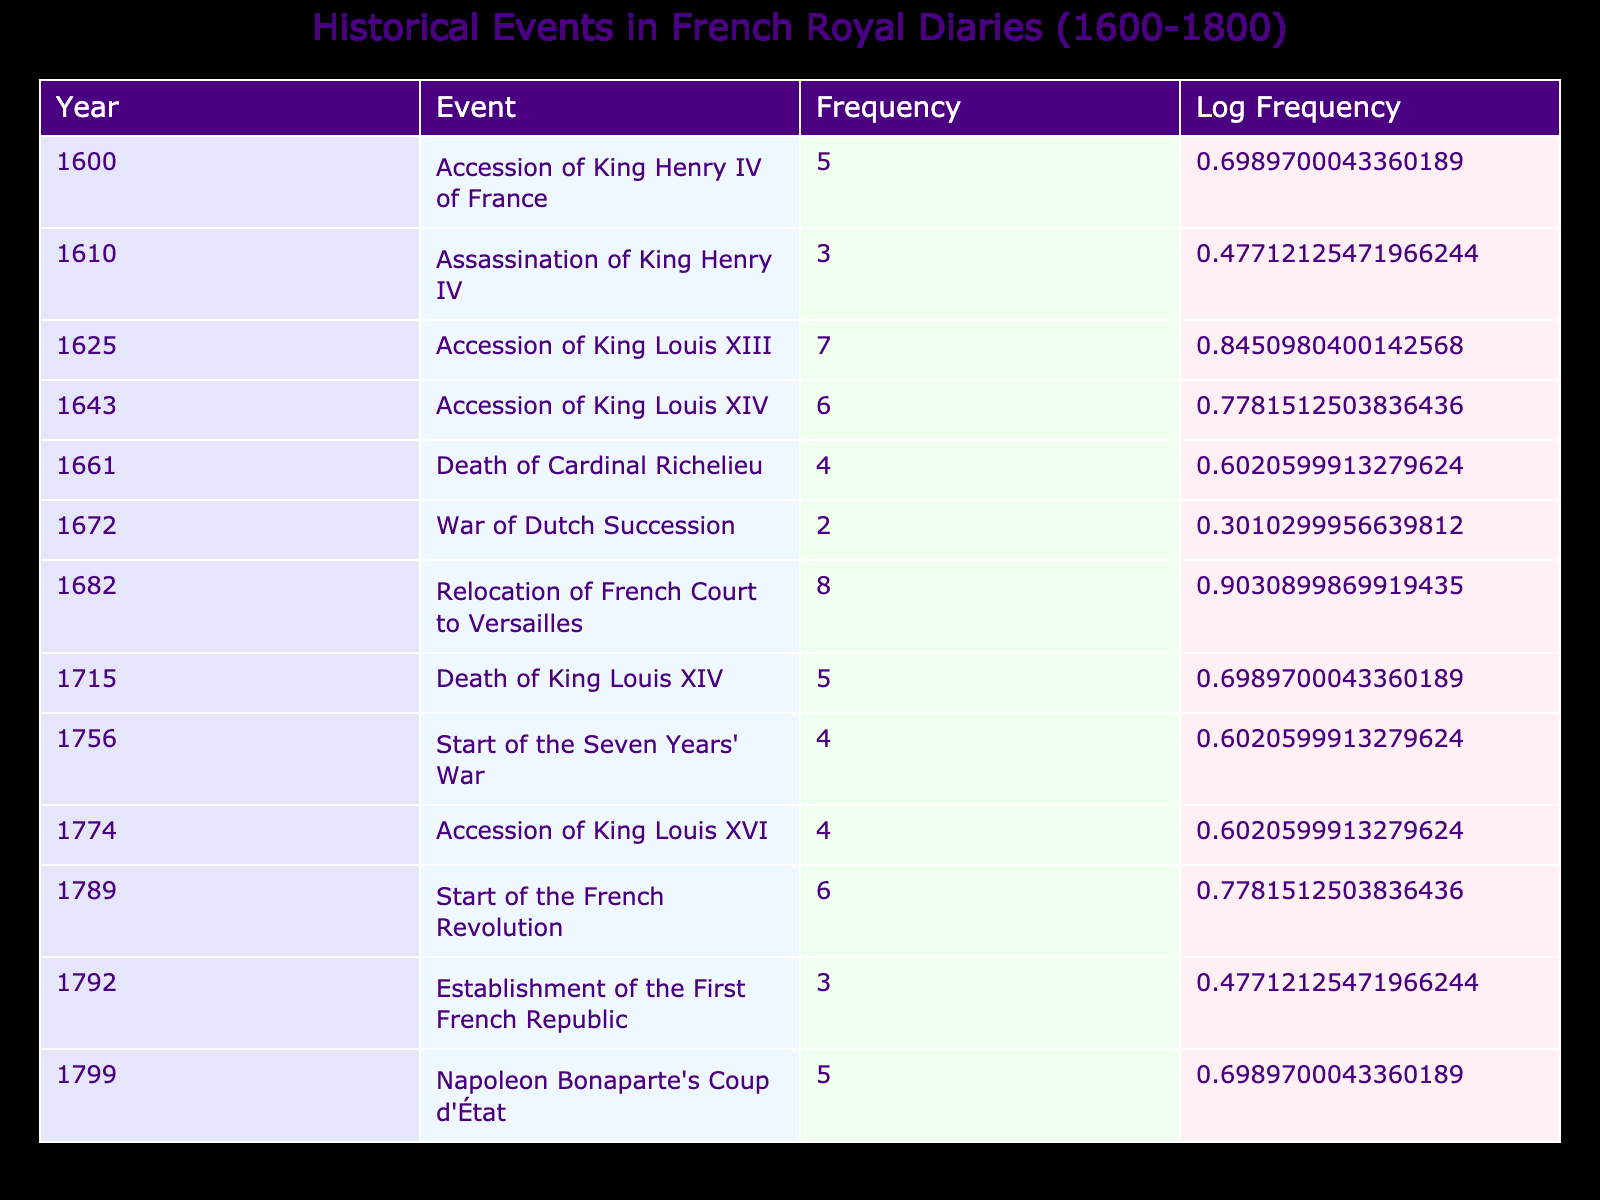What is the frequency of the event "Accession of King Louis XIV"? The table states that the frequency of the event "Accession of King Louis XIV" in the year 1643 is 6.
Answer: 6 How many events were recorded with a frequency of 4 or more? By examining the frequencies in the table, the events with frequencies of 4 or more are: Accession of King Louis XIII (7), Accession of King Louis XIV (6), Relocation of French Court to Versailles (8), Death of King Louis XIV (5), Start of the Seven Years' War (4), Accession of King Louis XVI (4), Start of the French Revolution (6), and Napoleon Bonaparte's Coup d'État (5). There are 8 such events.
Answer: 8 Which event had the highest frequency, and what was that frequency? Looking through the frequency column, the event with the highest frequency is "Relocation of French Court to Versailles," which has a frequency of 8.
Answer: Relocation of French Court to Versailles; 8 What is the median frequency of all events listed? To find the median frequency, we first list all frequencies: 5, 3, 7, 6, 4, 2, 8, 5, 4, 4, 6, 3, 5. After sorting them, we get: 2, 3, 3, 4, 4, 4, 5, 5, 5, 6, 6, 7, 8. Since there are 13 frequencies (odd number), the median is the value in the middle position, which is the 7th value: 5.
Answer: 5 Is there an instance of a royal event between 1700 and 1800 that has a frequency of 2? The table shows that the event "War of Dutch Succession" in 1672 has a frequency of 2, but there are no events between 1700 and 1800 with a frequency of 2, as the lowest recorded frequency in that range is 3.
Answer: No What is the total frequency of all events recorded in the table? To find the total frequency, we add all the frequencies together: 5 + 3 + 7 + 6 + 4 + 2 + 8 + 5 + 4 + 4 + 6 + 3 + 5 =  58.
Answer: 58 How many events occurred in the 1700s that have the same frequency? From the table, events in the 1700s are: Death of King Louis XIV (5), Start of the Seven Years' War (4), Accession of King Louis XVI (4). The frequencies for these events are 5 and 4. There are two events (Start of the Seven Years' War and Accession of King Louis XVI) with a frequency of 4.
Answer: 2 Which year saw the assassination of a king, and what was the frequency of that event? According to the table, the assassination of King Henry IV occurred in the year 1610, with a frequency of 3.
Answer: 1610; 3 